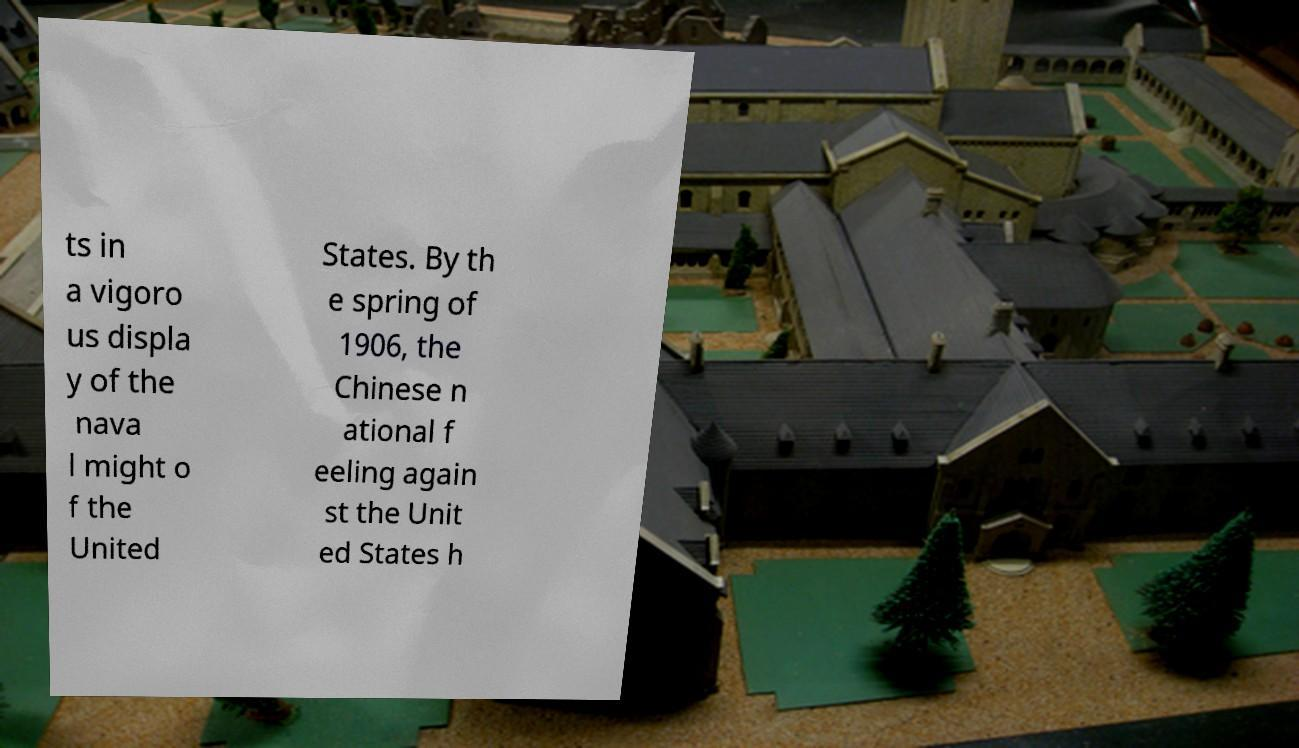What messages or text are displayed in this image? I need them in a readable, typed format. ts in a vigoro us displa y of the nava l might o f the United States. By th e spring of 1906, the Chinese n ational f eeling again st the Unit ed States h 